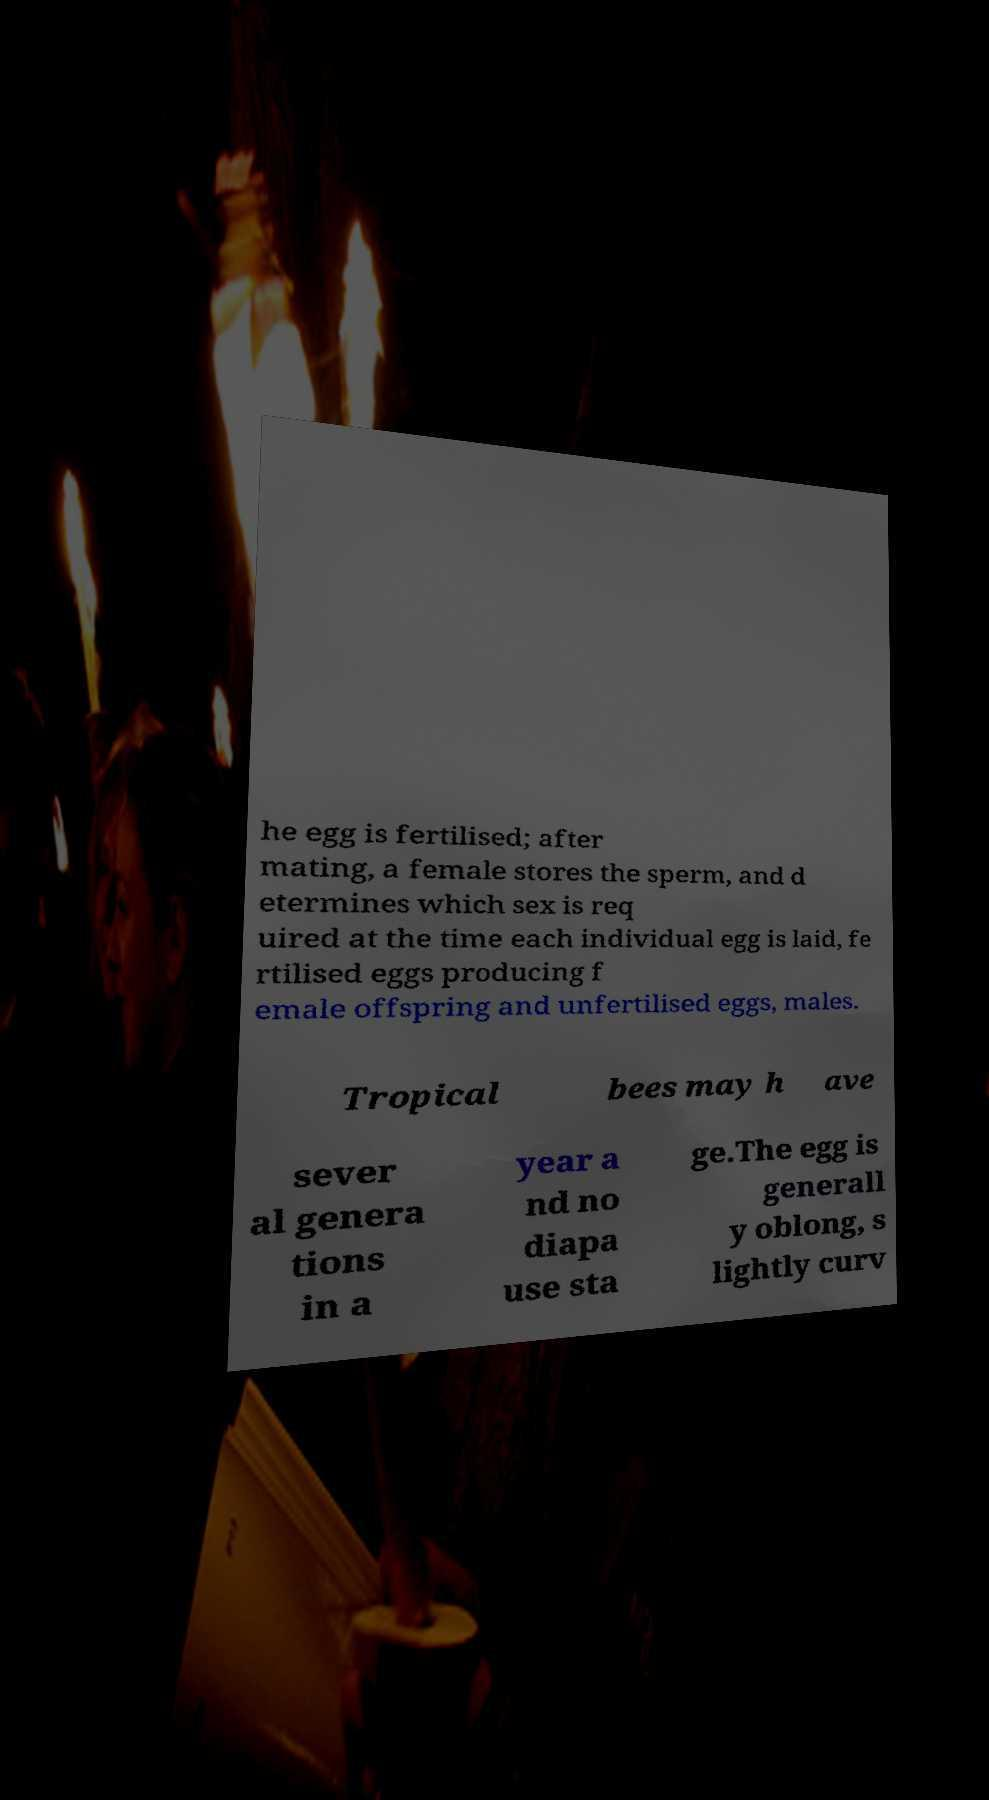Could you assist in decoding the text presented in this image and type it out clearly? he egg is fertilised; after mating, a female stores the sperm, and d etermines which sex is req uired at the time each individual egg is laid, fe rtilised eggs producing f emale offspring and unfertilised eggs, males. Tropical bees may h ave sever al genera tions in a year a nd no diapa use sta ge.The egg is generall y oblong, s lightly curv 